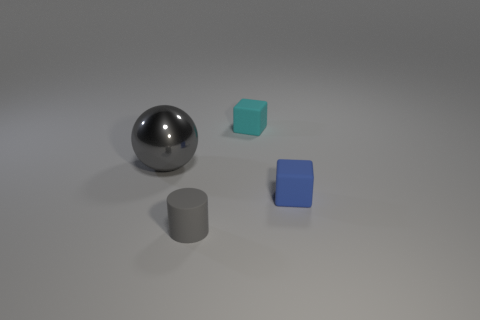There is another thing that is the same shape as the tiny blue object; what is it made of?
Ensure brevity in your answer.  Rubber. There is a small object that is on the right side of the small cyan rubber block; is it the same shape as the large gray thing?
Offer a very short reply. No. Is there anything else that is the same size as the cyan matte thing?
Provide a short and direct response. Yes. Is the number of gray metal spheres to the right of the ball less than the number of cylinders that are right of the blue object?
Make the answer very short. No. What number of other things are the same shape as the tiny gray matte object?
Provide a short and direct response. 0. There is a gray object to the left of the tiny object that is in front of the tiny matte object right of the tiny cyan matte object; what is its size?
Ensure brevity in your answer.  Large. How many yellow objects are either matte objects or big metal things?
Offer a very short reply. 0. What shape is the gray object that is to the left of the small matte thing in front of the tiny blue matte thing?
Offer a terse response. Sphere. There is a gray object that is behind the tiny blue rubber thing; does it have the same size as the object that is behind the gray shiny thing?
Ensure brevity in your answer.  No. Are there any tiny gray cylinders that have the same material as the big gray thing?
Give a very brief answer. No. 